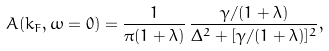Convert formula to latex. <formula><loc_0><loc_0><loc_500><loc_500>A ( { k } _ { F } , \omega = 0 ) = \frac { 1 } { \pi ( 1 + \lambda ) } \, \frac { \gamma / ( 1 + \lambda ) } { \Delta ^ { 2 } + [ \gamma / ( 1 + \lambda ) ] ^ { 2 } } ,</formula> 